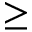Convert formula to latex. <formula><loc_0><loc_0><loc_500><loc_500>\geq</formula> 